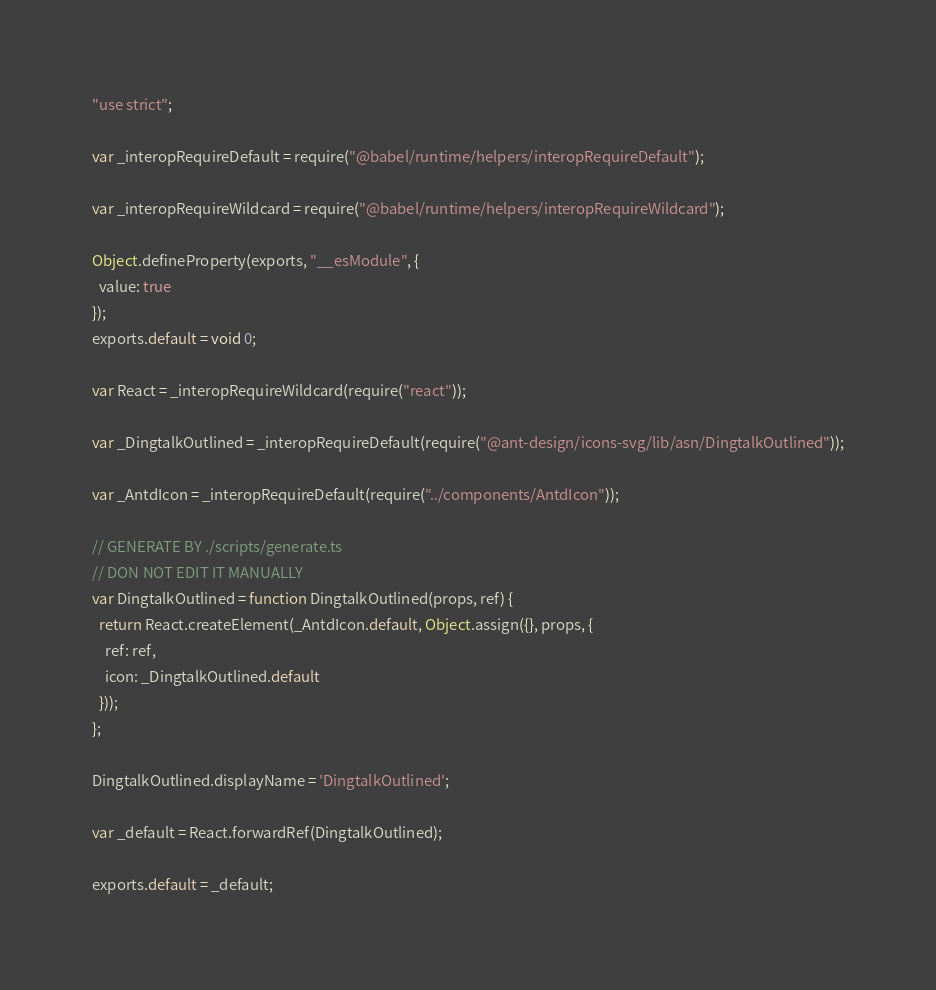Convert code to text. <code><loc_0><loc_0><loc_500><loc_500><_JavaScript_>"use strict";

var _interopRequireDefault = require("@babel/runtime/helpers/interopRequireDefault");

var _interopRequireWildcard = require("@babel/runtime/helpers/interopRequireWildcard");

Object.defineProperty(exports, "__esModule", {
  value: true
});
exports.default = void 0;

var React = _interopRequireWildcard(require("react"));

var _DingtalkOutlined = _interopRequireDefault(require("@ant-design/icons-svg/lib/asn/DingtalkOutlined"));

var _AntdIcon = _interopRequireDefault(require("../components/AntdIcon"));

// GENERATE BY ./scripts/generate.ts
// DON NOT EDIT IT MANUALLY
var DingtalkOutlined = function DingtalkOutlined(props, ref) {
  return React.createElement(_AntdIcon.default, Object.assign({}, props, {
    ref: ref,
    icon: _DingtalkOutlined.default
  }));
};

DingtalkOutlined.displayName = 'DingtalkOutlined';

var _default = React.forwardRef(DingtalkOutlined);

exports.default = _default;</code> 